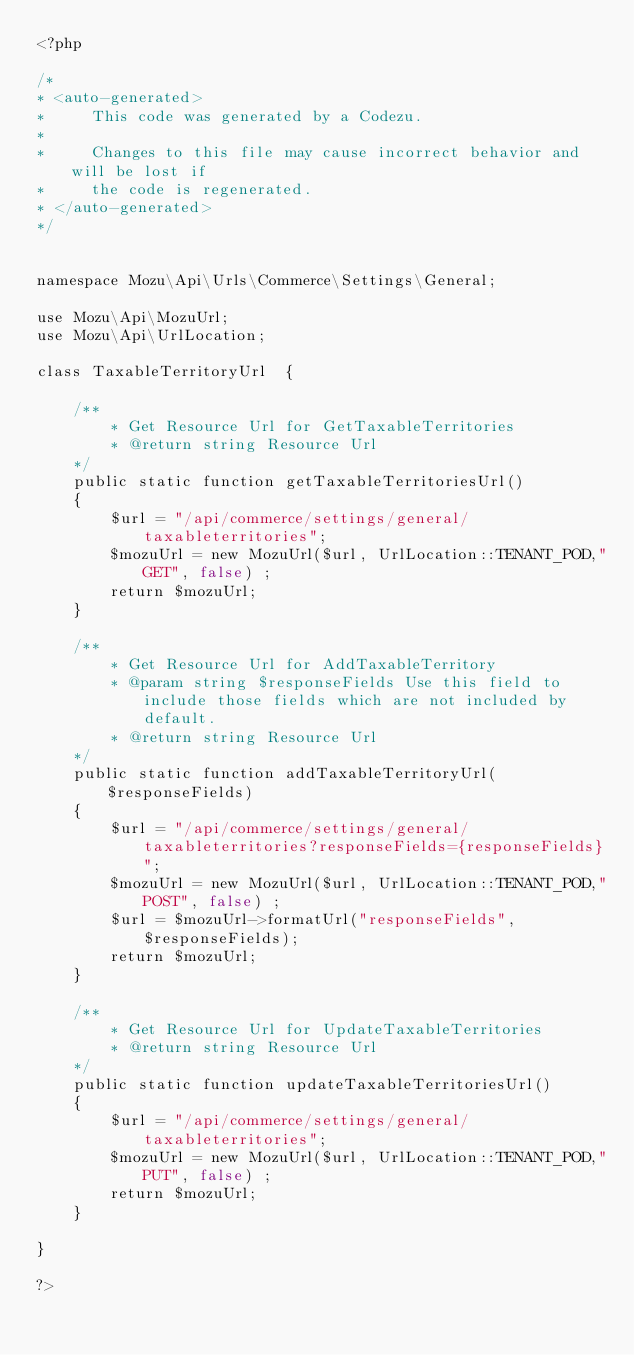<code> <loc_0><loc_0><loc_500><loc_500><_PHP_><?php

/*
* <auto-generated>
*     This code was generated by a Codezu.     
*
*     Changes to this file may cause incorrect behavior and will be lost if
*     the code is regenerated.
* </auto-generated>
*/


namespace Mozu\Api\Urls\Commerce\Settings\General;

use Mozu\Api\MozuUrl;
use Mozu\Api\UrlLocation;

class TaxableTerritoryUrl  {

	/**
		* Get Resource Url for GetTaxableTerritories
		* @return string Resource Url
	*/
	public static function getTaxableTerritoriesUrl()
	{
		$url = "/api/commerce/settings/general/taxableterritories";
		$mozuUrl = new MozuUrl($url, UrlLocation::TENANT_POD,"GET", false) ;
		return $mozuUrl;
	}
	
	/**
		* Get Resource Url for AddTaxableTerritory
		* @param string $responseFields Use this field to include those fields which are not included by default.
		* @return string Resource Url
	*/
	public static function addTaxableTerritoryUrl($responseFields)
	{
		$url = "/api/commerce/settings/general/taxableterritories?responseFields={responseFields}";
		$mozuUrl = new MozuUrl($url, UrlLocation::TENANT_POD,"POST", false) ;
		$url = $mozuUrl->formatUrl("responseFields", $responseFields);
		return $mozuUrl;
	}
	
	/**
		* Get Resource Url for UpdateTaxableTerritories
		* @return string Resource Url
	*/
	public static function updateTaxableTerritoriesUrl()
	{
		$url = "/api/commerce/settings/general/taxableterritories";
		$mozuUrl = new MozuUrl($url, UrlLocation::TENANT_POD,"PUT", false) ;
		return $mozuUrl;
	}
	
}

?>

</code> 